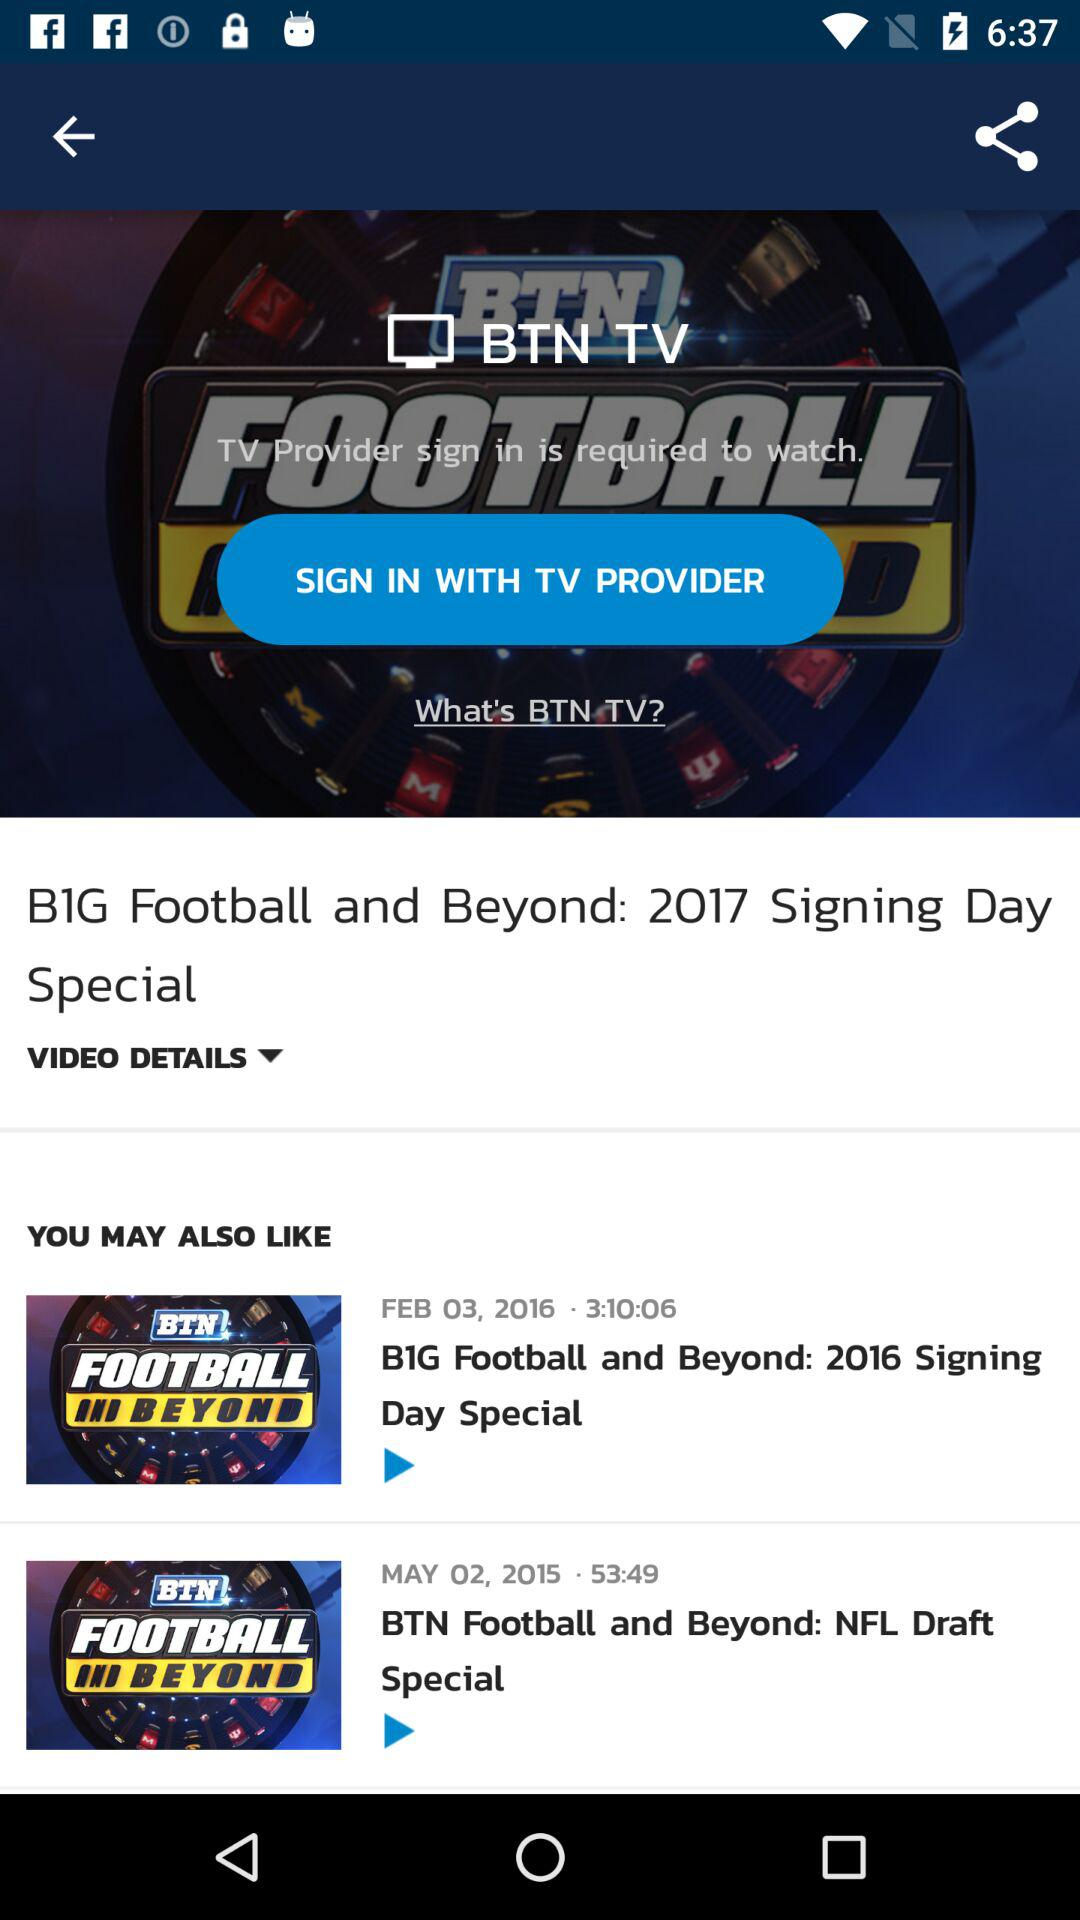What is the posted date of the video "BTN Football and Beyond: NFL Draft Special"? The posted date of the video is May 02, 2015. 